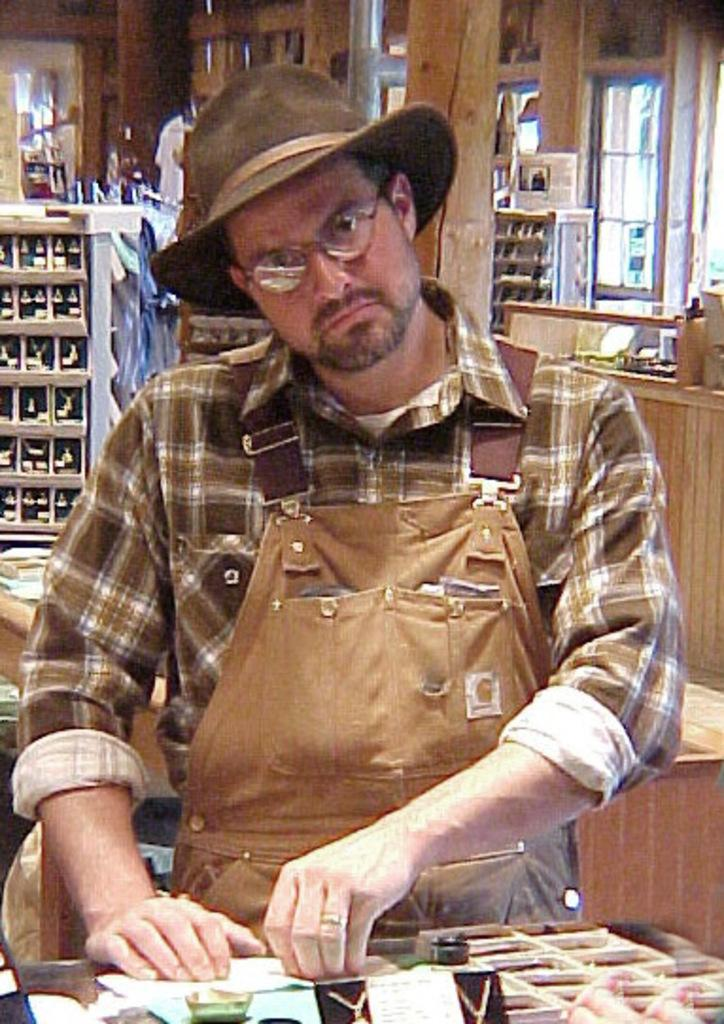What is the main subject of the image? There is a man in the image. Can you describe the man's appearance? The man is wearing spectacles and a cap. What can be seen on the table in the image? There are objects on a table in the image. What is visible in the background of the image? There are bottles on racks, poles, and windows visible in the background of the image. How does the zephyr affect the man's attention in the image? There is no mention of a zephyr or any effect on the man's attention in the image. What color is the orange in the image? There is no orange present in the image. 